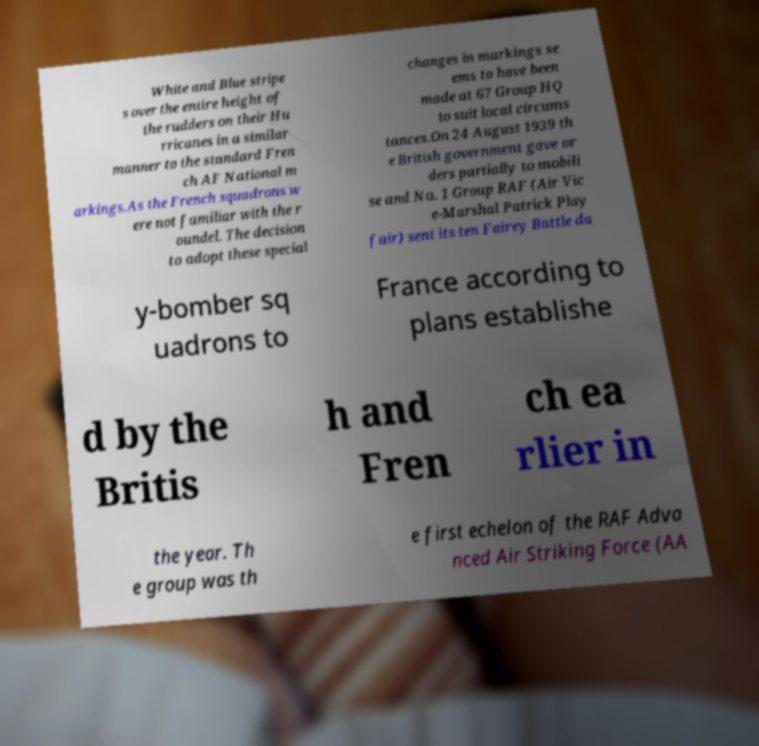Could you extract and type out the text from this image? White and Blue stripe s over the entire height of the rudders on their Hu rricanes in a similar manner to the standard Fren ch AF National m arkings.As the French squadrons w ere not familiar with the r oundel. The decision to adopt these special changes in markings se ems to have been made at 67 Group HQ to suit local circums tances.On 24 August 1939 th e British government gave or ders partially to mobili se and No. 1 Group RAF (Air Vic e-Marshal Patrick Play fair) sent its ten Fairey Battle da y-bomber sq uadrons to France according to plans establishe d by the Britis h and Fren ch ea rlier in the year. Th e group was th e first echelon of the RAF Adva nced Air Striking Force (AA 